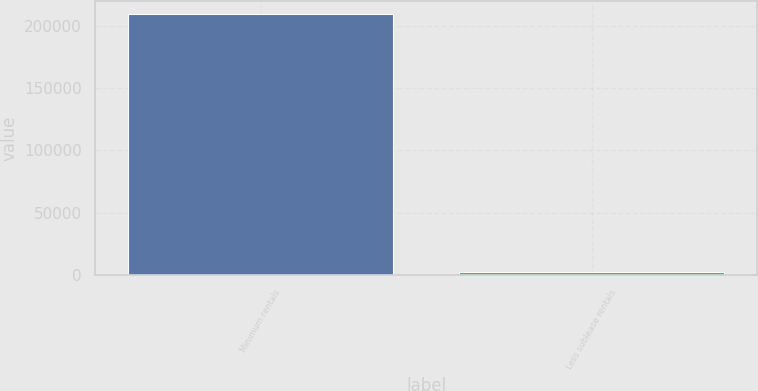Convert chart. <chart><loc_0><loc_0><loc_500><loc_500><bar_chart><fcel>Minimum rentals<fcel>Less sublease rentals<nl><fcel>209307<fcel>2457<nl></chart> 